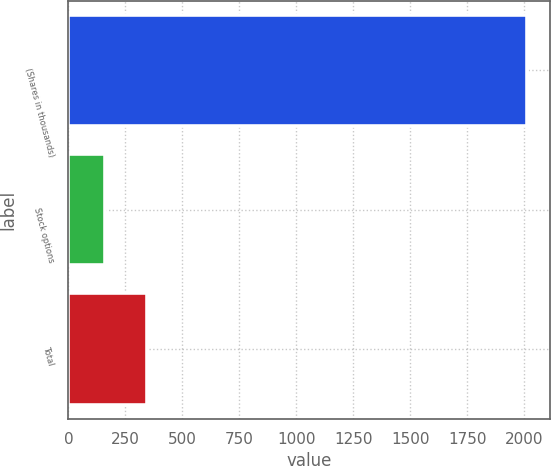Convert chart. <chart><loc_0><loc_0><loc_500><loc_500><bar_chart><fcel>(Shares in thousands)<fcel>Stock options<fcel>Total<nl><fcel>2014<fcel>161<fcel>346.3<nl></chart> 